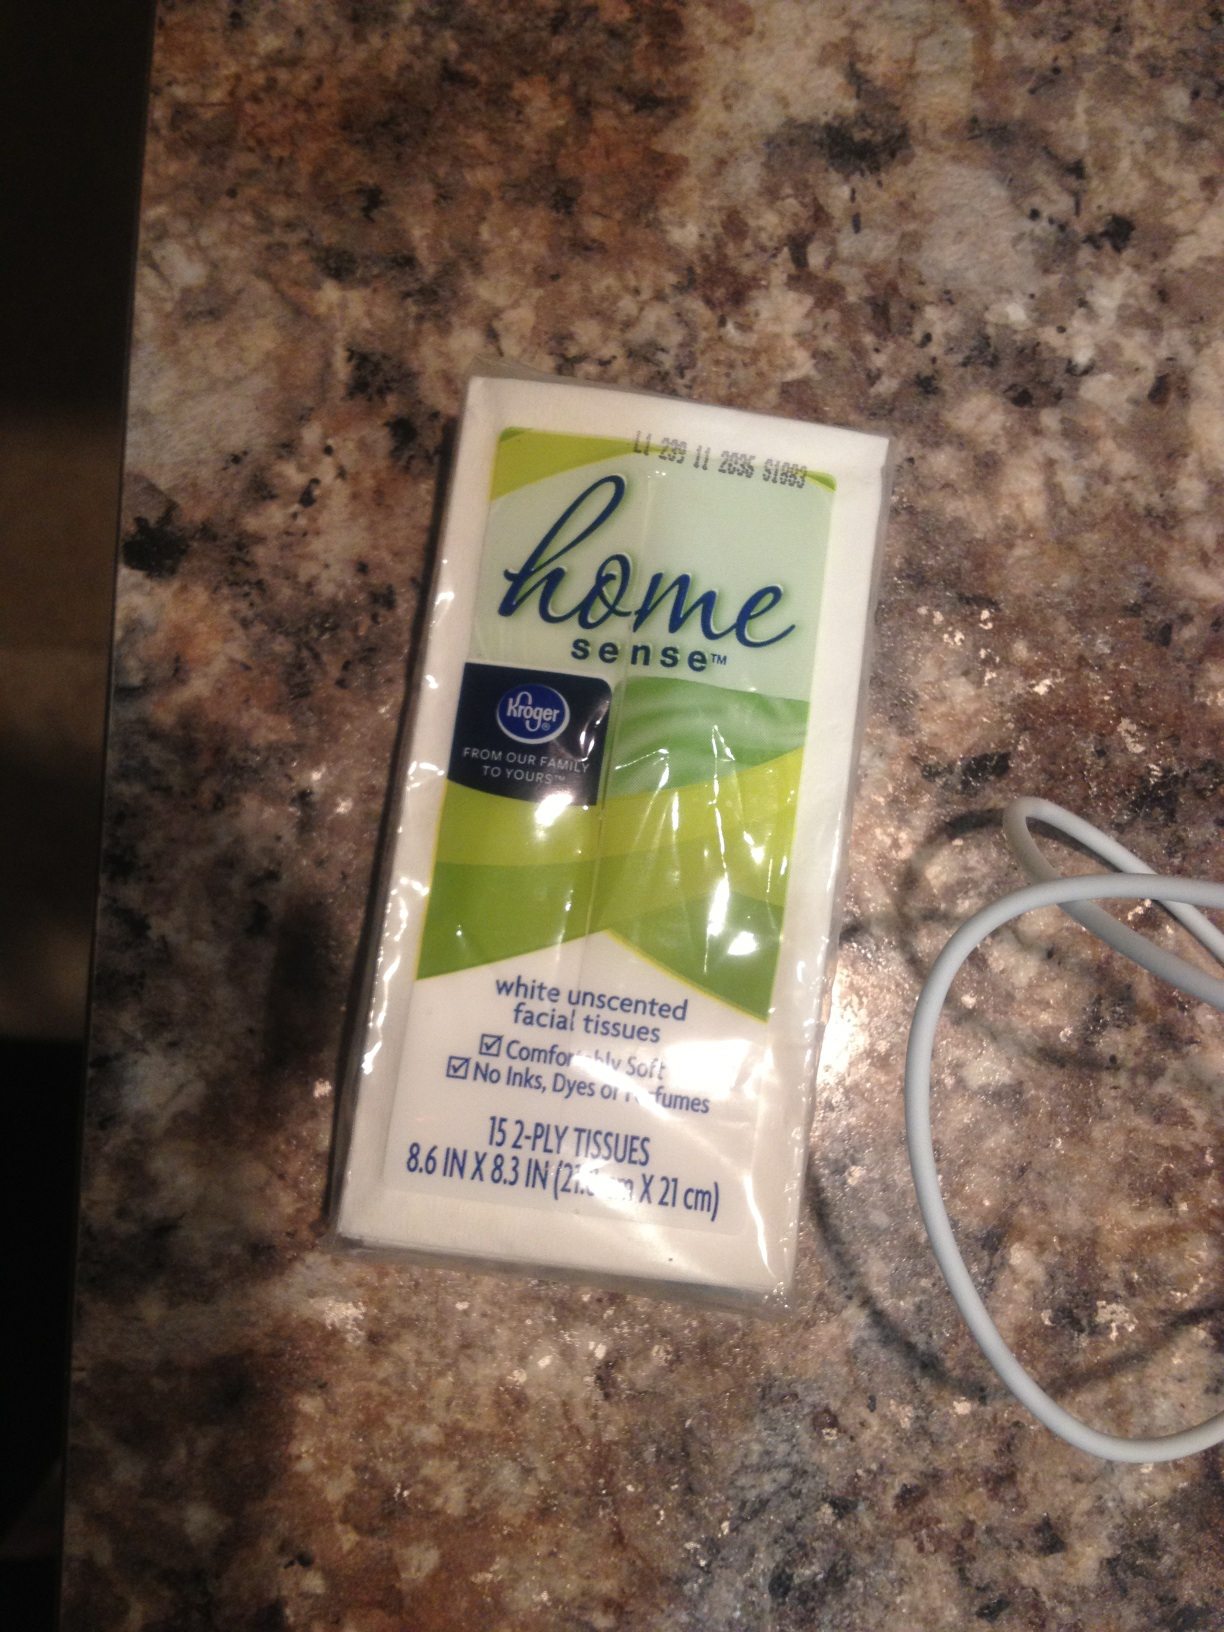Describe a scenario where having this product would be extremely useful. Imagine you're on a road trip with your family and someone accidentally spills juice in the car. These Home Sense facial tissues would be a lifesaver for quickly soaking up the spill and cleaning sticky hands. They are also useful for unexpected moments where you need to wipe off sweat or clean your face, maintaining hygiene while traveling. 